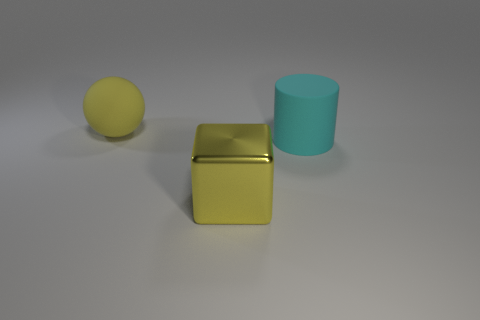What shape is the rubber thing that is the same color as the block?
Your answer should be compact. Sphere. What is the size of the cyan thing that is the same material as the big ball?
Your response must be concise. Large. Is the size of the metal cube the same as the matte object to the right of the large yellow matte object?
Your answer should be compact. Yes. The large object that is both behind the shiny object and to the right of the large yellow matte ball is what color?
Keep it short and to the point. Cyan. How many things are large matte things on the left side of the matte cylinder or things that are in front of the yellow rubber object?
Give a very brief answer. 3. What color is the rubber object in front of the big rubber object on the left side of the big object on the right side of the large metallic object?
Your answer should be very brief. Cyan. Are there any other shiny things of the same shape as the big cyan object?
Offer a terse response. No. What number of yellow cubes are there?
Provide a short and direct response. 1. The yellow rubber object has what shape?
Make the answer very short. Sphere. How many other cyan cylinders have the same size as the cyan matte cylinder?
Your response must be concise. 0. 